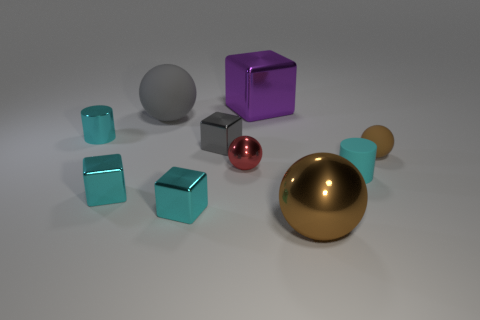How many tiny spheres are to the left of the tiny brown rubber object? 1 